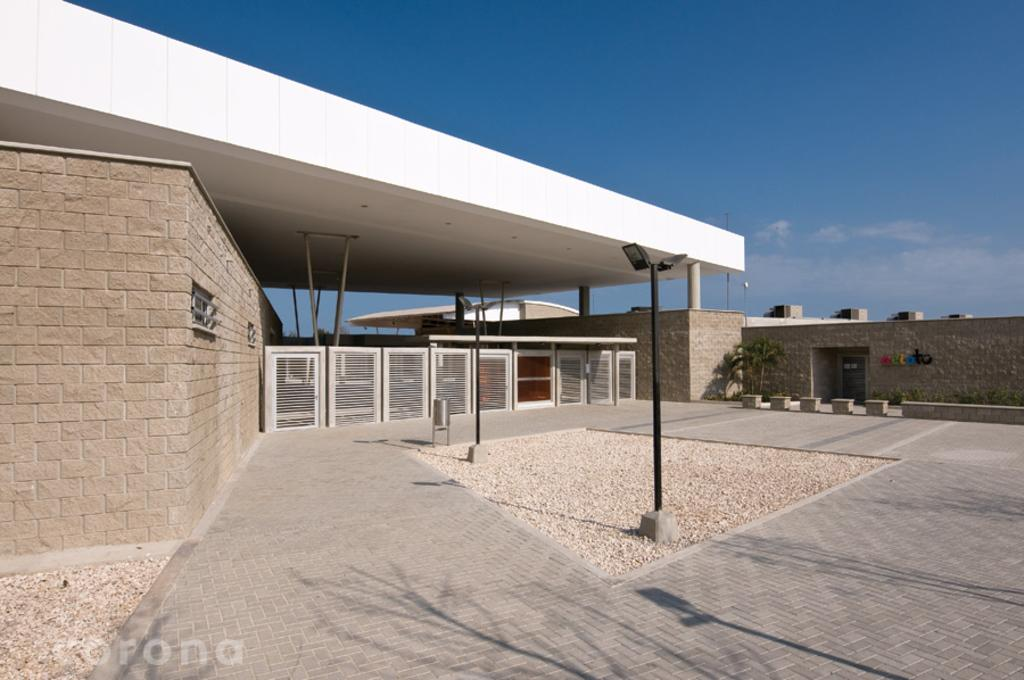What type of structures can be seen in the image? There are buildings in the image. What other elements are present in the image besides buildings? There are plants in the image. What is visible at the top of the image? The sky is visible at the top of the image. What type of tank can be seen in the image? There is no tank present in the image. How do the plants in the image turn towards the sun? The plants in the image do not move or turn towards the sun; they are stationary. 